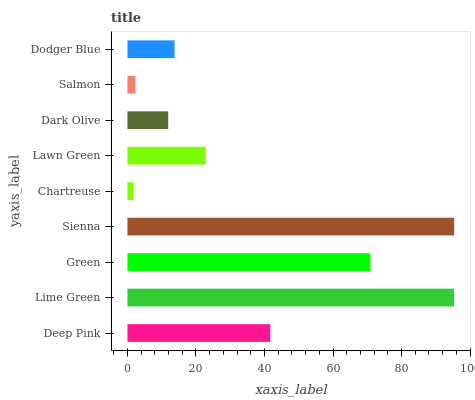Is Chartreuse the minimum?
Answer yes or no. Yes. Is Sienna the maximum?
Answer yes or no. Yes. Is Lime Green the minimum?
Answer yes or no. No. Is Lime Green the maximum?
Answer yes or no. No. Is Lime Green greater than Deep Pink?
Answer yes or no. Yes. Is Deep Pink less than Lime Green?
Answer yes or no. Yes. Is Deep Pink greater than Lime Green?
Answer yes or no. No. Is Lime Green less than Deep Pink?
Answer yes or no. No. Is Lawn Green the high median?
Answer yes or no. Yes. Is Lawn Green the low median?
Answer yes or no. Yes. Is Lime Green the high median?
Answer yes or no. No. Is Salmon the low median?
Answer yes or no. No. 